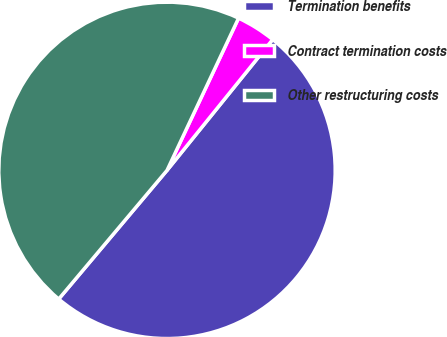Convert chart to OTSL. <chart><loc_0><loc_0><loc_500><loc_500><pie_chart><fcel>Termination benefits<fcel>Contract termination costs<fcel>Other restructuring costs<nl><fcel>50.32%<fcel>3.82%<fcel>45.86%<nl></chart> 